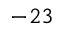<formula> <loc_0><loc_0><loc_500><loc_500>^ { - 2 3 }</formula> 